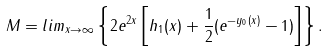<formula> <loc_0><loc_0><loc_500><loc_500>M = l i m _ { x \rightarrow \infty } \left \{ 2 e ^ { 2 x } \left [ h _ { 1 } ( x ) + \frac { 1 } { 2 } ( e ^ { - y _ { 0 } ( x ) } - 1 ) \right ] \right \} .</formula> 